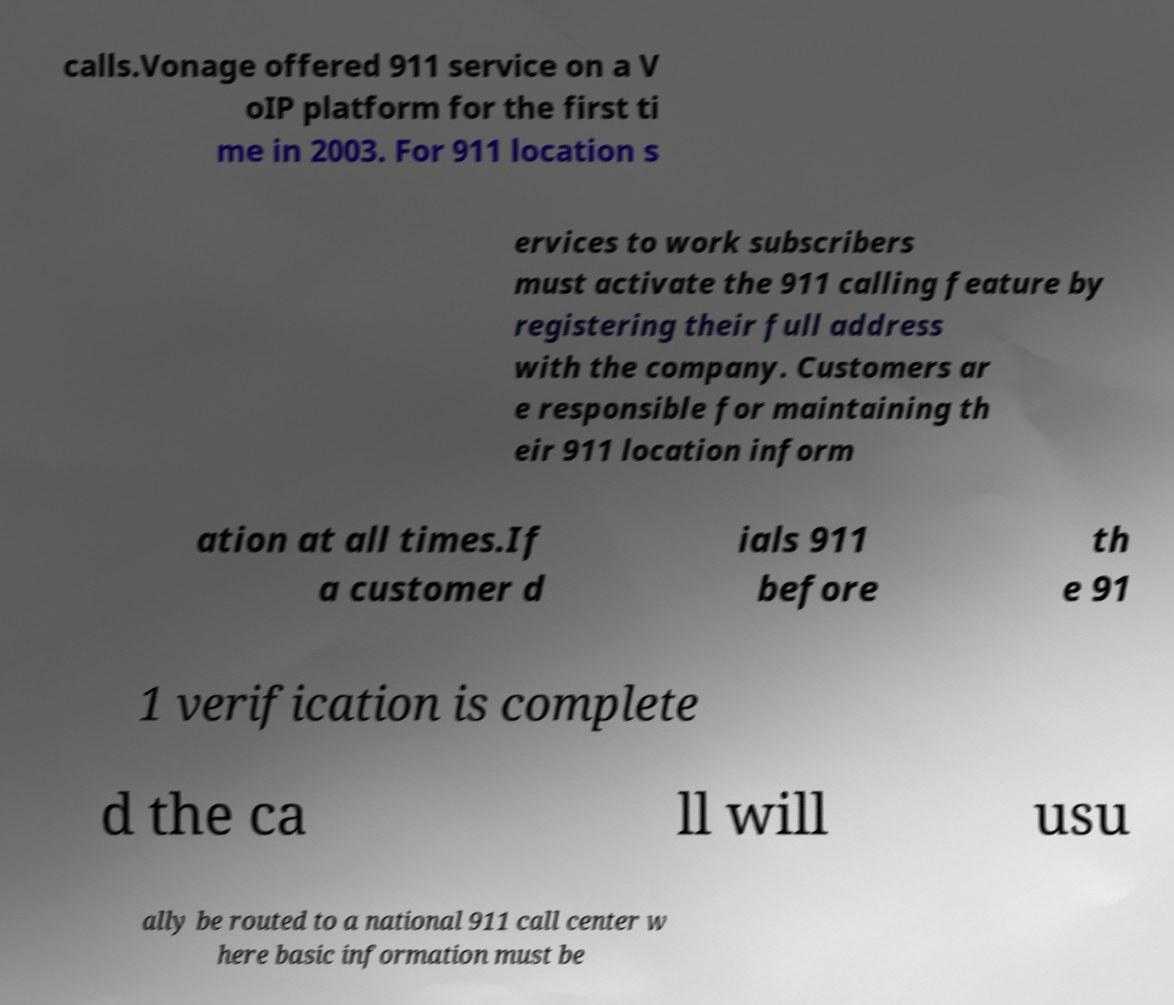What messages or text are displayed in this image? I need them in a readable, typed format. calls.Vonage offered 911 service on a V oIP platform for the first ti me in 2003. For 911 location s ervices to work subscribers must activate the 911 calling feature by registering their full address with the company. Customers ar e responsible for maintaining th eir 911 location inform ation at all times.If a customer d ials 911 before th e 91 1 verification is complete d the ca ll will usu ally be routed to a national 911 call center w here basic information must be 